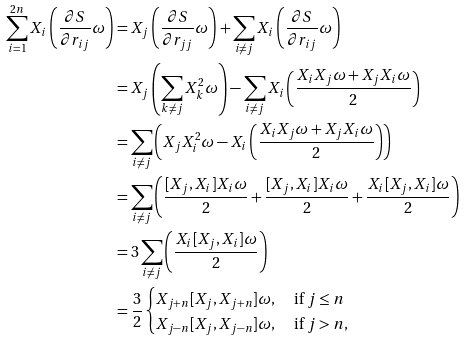<formula> <loc_0><loc_0><loc_500><loc_500>\sum _ { i = 1 } ^ { 2 n } X _ { i } \left ( \frac { \partial S } { \partial r _ { i j } } \omega \right ) & = X _ { j } \left ( \frac { \partial S } { \partial r _ { j j } } \omega \right ) + \sum _ { i \neq j } X _ { i } \left ( \frac { \partial S } { \partial r _ { i j } } \omega \right ) \\ & = X _ { j } \left ( \sum _ { k \neq j } X ^ { 2 } _ { k } \omega \right ) - \sum _ { i \neq j } X _ { i } \left ( \frac { X _ { i } X _ { j } \omega + X _ { j } X _ { i } \omega } { 2 } \right ) \\ & = \sum _ { i \neq j } \left ( X _ { j } X ^ { 2 } _ { i } \omega - X _ { i } \left ( \frac { X _ { i } X _ { j } \omega + X _ { j } X _ { i } \omega } { 2 } \right ) \right ) \\ & = \sum _ { i \neq j } \left ( \frac { [ X _ { j } , X _ { i } ] X _ { i } \omega } { 2 } + \frac { [ X _ { j } , X _ { i } ] X _ { i } \omega } { 2 } + \frac { X _ { i } [ X _ { j } , X _ { i } ] \omega } { 2 } \right ) \\ & = { 3 } \sum _ { i \neq j } \left ( \frac { X _ { i } [ X _ { j } , X _ { i } ] \omega } { 2 } \right ) \\ & = \frac { 3 } { 2 } \begin{cases} X _ { j + n } [ X _ { j } , X _ { j + n } ] \omega , & \text { if $j\leq n$} \\ X _ { j - n } [ X _ { j } , X _ { j - n } ] \omega , & \text { if $j > n$} , \end{cases}</formula> 